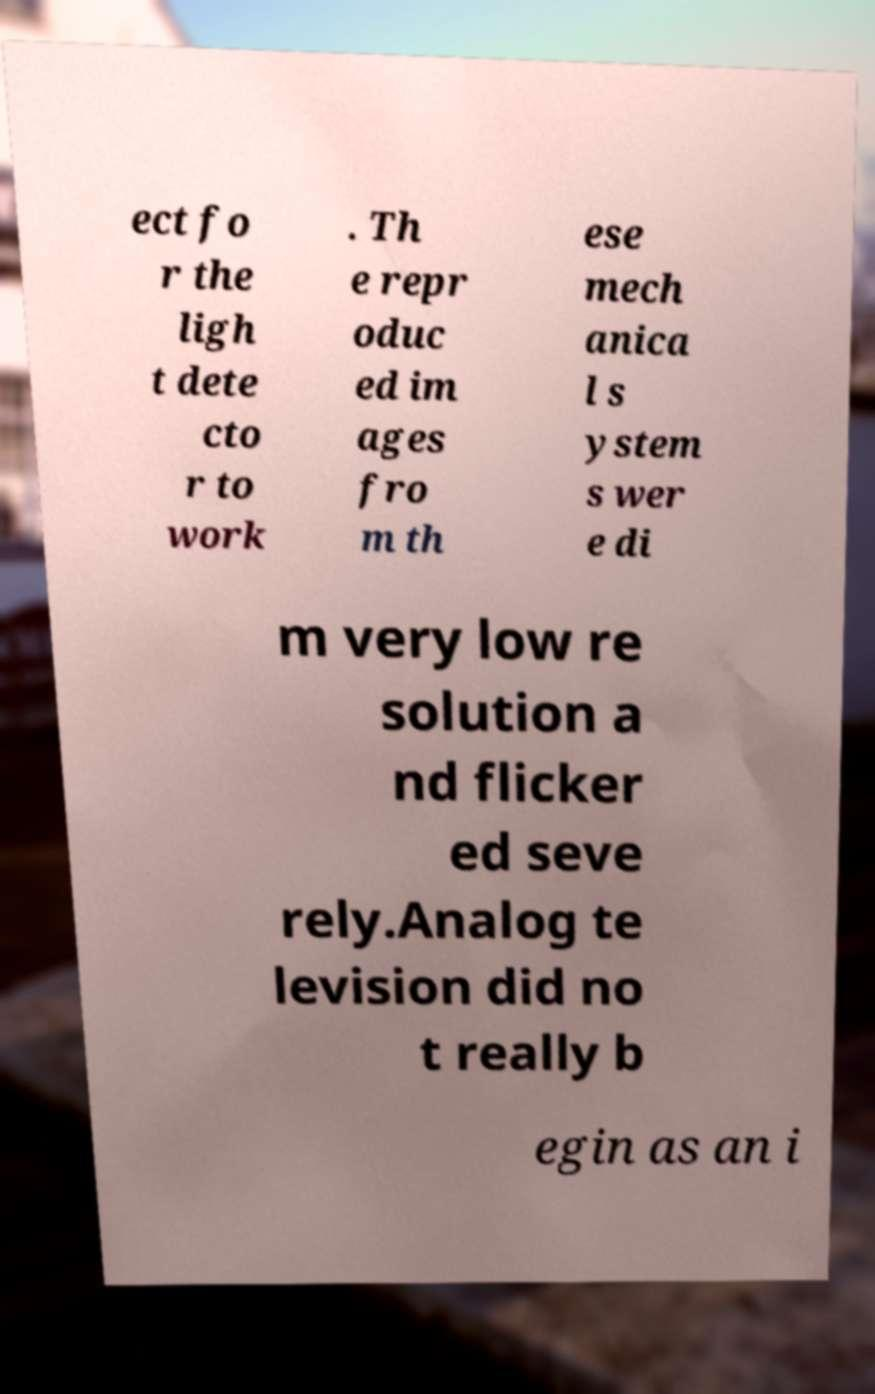I need the written content from this picture converted into text. Can you do that? ect fo r the ligh t dete cto r to work . Th e repr oduc ed im ages fro m th ese mech anica l s ystem s wer e di m very low re solution a nd flicker ed seve rely.Analog te levision did no t really b egin as an i 